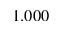Convert formula to latex. <formula><loc_0><loc_0><loc_500><loc_500>1 . 0 0 0</formula> 